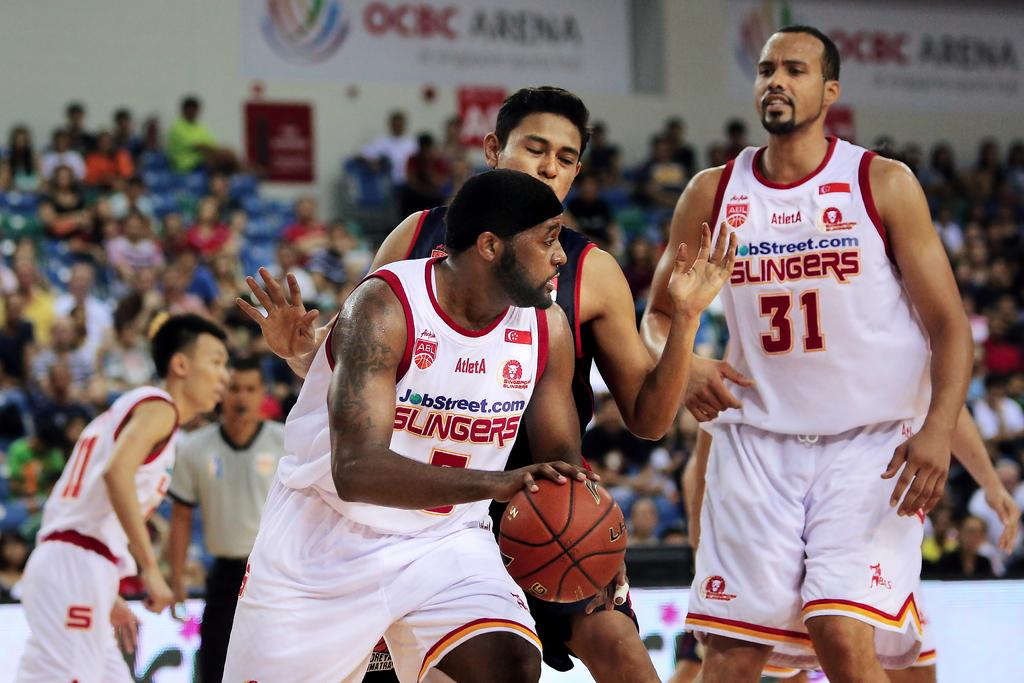<image>
Provide a brief description of the given image. A basketball player has the number 31 on his jersey. 